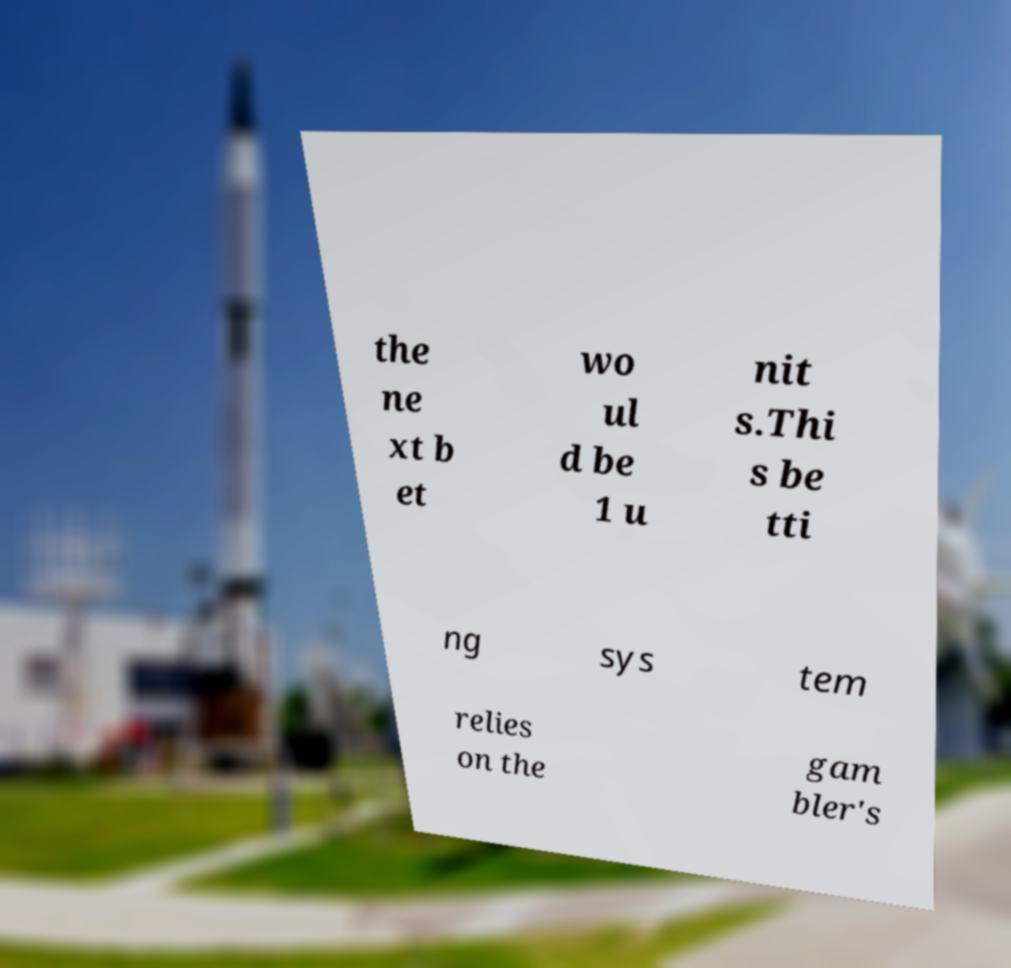For documentation purposes, I need the text within this image transcribed. Could you provide that? the ne xt b et wo ul d be 1 u nit s.Thi s be tti ng sys tem relies on the gam bler's 